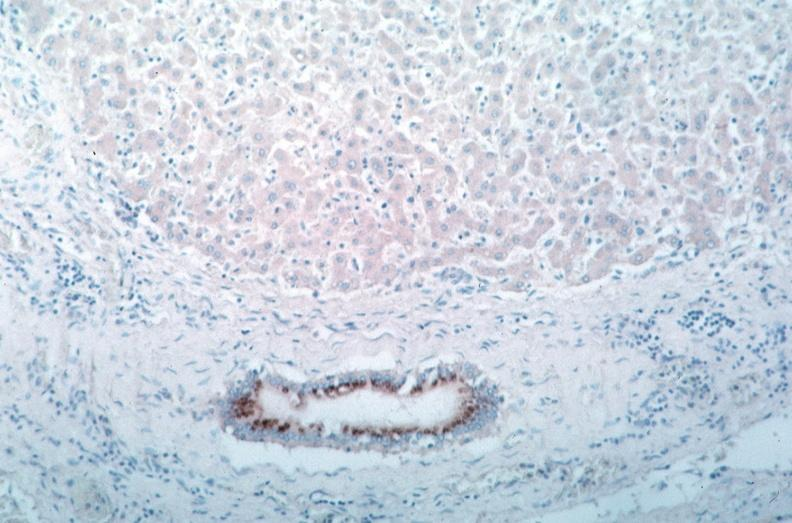what does this image show?
Answer the question using a single word or phrase. Vasculitis 